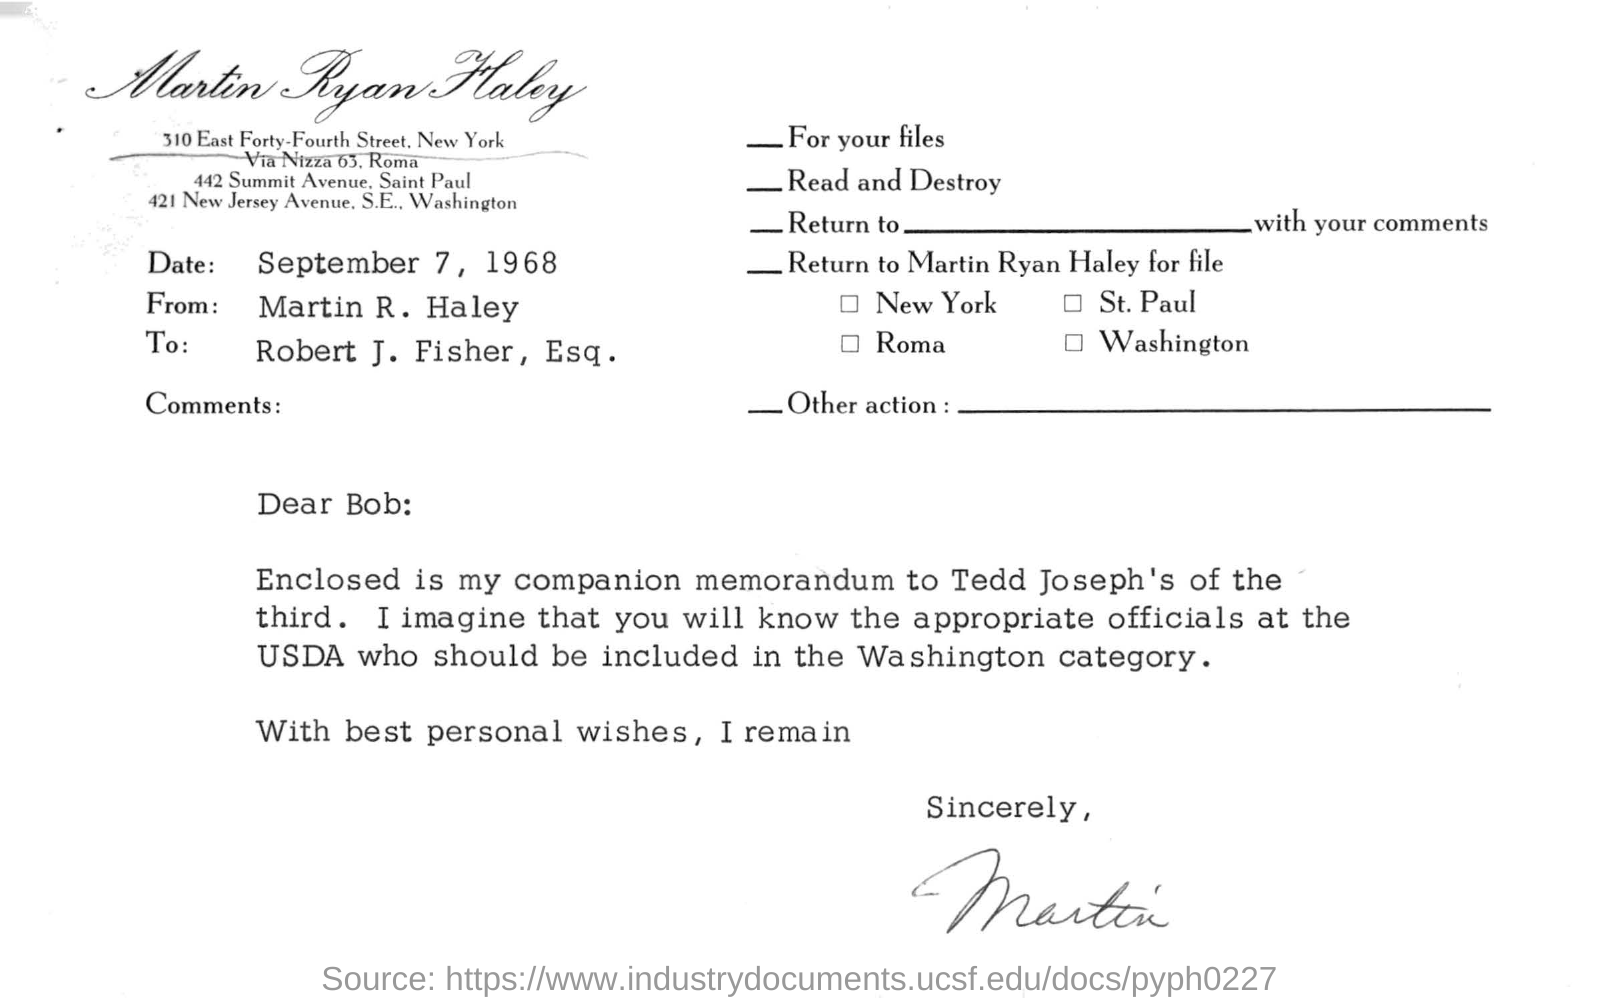Who is this letter from?
Keep it short and to the point. Martin R. Haley. What is the date mentioned in this letter?
Provide a succinct answer. September 7, 1968. 